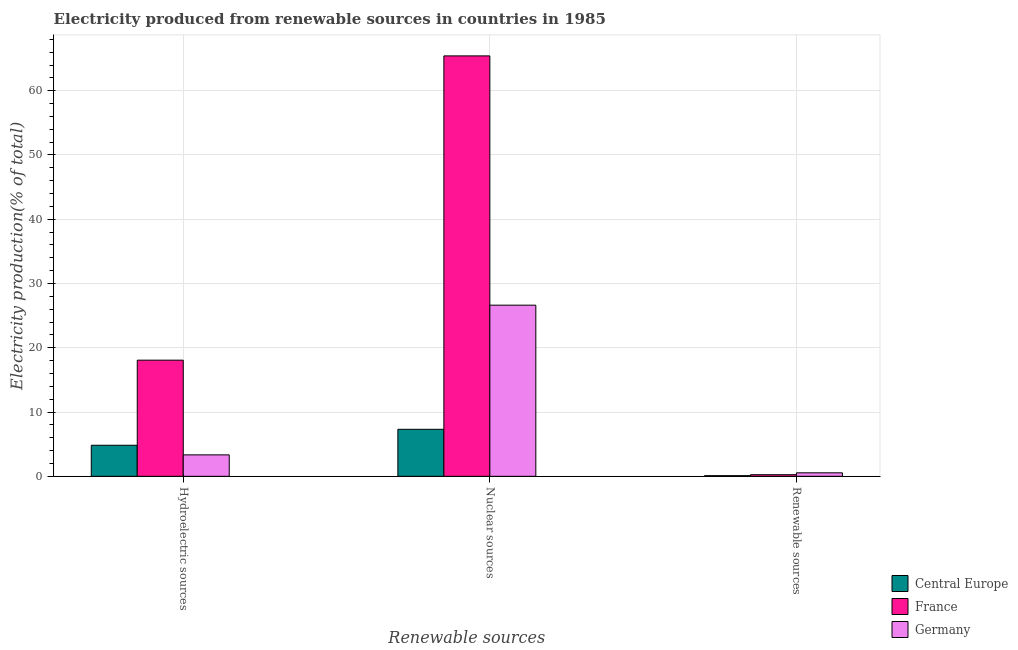How many different coloured bars are there?
Make the answer very short. 3. How many groups of bars are there?
Provide a short and direct response. 3. What is the label of the 3rd group of bars from the left?
Your answer should be very brief. Renewable sources. What is the percentage of electricity produced by renewable sources in Germany?
Your answer should be compact. 0.54. Across all countries, what is the maximum percentage of electricity produced by nuclear sources?
Give a very brief answer. 65.42. Across all countries, what is the minimum percentage of electricity produced by hydroelectric sources?
Ensure brevity in your answer.  3.34. What is the total percentage of electricity produced by renewable sources in the graph?
Your answer should be compact. 0.89. What is the difference between the percentage of electricity produced by hydroelectric sources in Central Europe and that in Germany?
Your response must be concise. 1.5. What is the difference between the percentage of electricity produced by hydroelectric sources in Germany and the percentage of electricity produced by renewable sources in Central Europe?
Provide a succinct answer. 3.24. What is the average percentage of electricity produced by hydroelectric sources per country?
Give a very brief answer. 8.75. What is the difference between the percentage of electricity produced by hydroelectric sources and percentage of electricity produced by nuclear sources in Central Europe?
Your response must be concise. -2.48. In how many countries, is the percentage of electricity produced by renewable sources greater than 8 %?
Keep it short and to the point. 0. What is the ratio of the percentage of electricity produced by nuclear sources in France to that in Central Europe?
Offer a very short reply. 8.94. What is the difference between the highest and the second highest percentage of electricity produced by renewable sources?
Provide a succinct answer. 0.29. What is the difference between the highest and the lowest percentage of electricity produced by renewable sources?
Provide a succinct answer. 0.44. What does the 1st bar from the left in Hydroelectric sources represents?
Keep it short and to the point. Central Europe. What does the 3rd bar from the right in Hydroelectric sources represents?
Your answer should be compact. Central Europe. Is it the case that in every country, the sum of the percentage of electricity produced by hydroelectric sources and percentage of electricity produced by nuclear sources is greater than the percentage of electricity produced by renewable sources?
Offer a terse response. Yes. Are all the bars in the graph horizontal?
Offer a terse response. No. Are the values on the major ticks of Y-axis written in scientific E-notation?
Your answer should be compact. No. How many legend labels are there?
Keep it short and to the point. 3. What is the title of the graph?
Keep it short and to the point. Electricity produced from renewable sources in countries in 1985. Does "Chile" appear as one of the legend labels in the graph?
Offer a terse response. No. What is the label or title of the X-axis?
Your answer should be very brief. Renewable sources. What is the label or title of the Y-axis?
Offer a very short reply. Electricity production(% of total). What is the Electricity production(% of total) of Central Europe in Hydroelectric sources?
Ensure brevity in your answer.  4.83. What is the Electricity production(% of total) of France in Hydroelectric sources?
Provide a succinct answer. 18.07. What is the Electricity production(% of total) in Germany in Hydroelectric sources?
Make the answer very short. 3.34. What is the Electricity production(% of total) of Central Europe in Nuclear sources?
Make the answer very short. 7.31. What is the Electricity production(% of total) of France in Nuclear sources?
Make the answer very short. 65.42. What is the Electricity production(% of total) of Germany in Nuclear sources?
Your response must be concise. 26.63. What is the Electricity production(% of total) of Central Europe in Renewable sources?
Provide a short and direct response. 0.1. What is the Electricity production(% of total) in France in Renewable sources?
Offer a terse response. 0.25. What is the Electricity production(% of total) in Germany in Renewable sources?
Provide a short and direct response. 0.54. Across all Renewable sources, what is the maximum Electricity production(% of total) in Central Europe?
Provide a short and direct response. 7.31. Across all Renewable sources, what is the maximum Electricity production(% of total) of France?
Your response must be concise. 65.42. Across all Renewable sources, what is the maximum Electricity production(% of total) of Germany?
Provide a succinct answer. 26.63. Across all Renewable sources, what is the minimum Electricity production(% of total) of Central Europe?
Keep it short and to the point. 0.1. Across all Renewable sources, what is the minimum Electricity production(% of total) of France?
Ensure brevity in your answer.  0.25. Across all Renewable sources, what is the minimum Electricity production(% of total) of Germany?
Your answer should be compact. 0.54. What is the total Electricity production(% of total) of Central Europe in the graph?
Your response must be concise. 12.25. What is the total Electricity production(% of total) of France in the graph?
Your answer should be very brief. 83.75. What is the total Electricity production(% of total) in Germany in the graph?
Provide a short and direct response. 30.51. What is the difference between the Electricity production(% of total) of Central Europe in Hydroelectric sources and that in Nuclear sources?
Give a very brief answer. -2.48. What is the difference between the Electricity production(% of total) in France in Hydroelectric sources and that in Nuclear sources?
Your answer should be very brief. -47.35. What is the difference between the Electricity production(% of total) of Germany in Hydroelectric sources and that in Nuclear sources?
Keep it short and to the point. -23.3. What is the difference between the Electricity production(% of total) in Central Europe in Hydroelectric sources and that in Renewable sources?
Your answer should be very brief. 4.73. What is the difference between the Electricity production(% of total) in France in Hydroelectric sources and that in Renewable sources?
Your answer should be very brief. 17.82. What is the difference between the Electricity production(% of total) in Germany in Hydroelectric sources and that in Renewable sources?
Keep it short and to the point. 2.79. What is the difference between the Electricity production(% of total) of Central Europe in Nuclear sources and that in Renewable sources?
Your answer should be compact. 7.22. What is the difference between the Electricity production(% of total) in France in Nuclear sources and that in Renewable sources?
Offer a very short reply. 65.17. What is the difference between the Electricity production(% of total) of Germany in Nuclear sources and that in Renewable sources?
Provide a short and direct response. 26.09. What is the difference between the Electricity production(% of total) in Central Europe in Hydroelectric sources and the Electricity production(% of total) in France in Nuclear sources?
Give a very brief answer. -60.59. What is the difference between the Electricity production(% of total) of Central Europe in Hydroelectric sources and the Electricity production(% of total) of Germany in Nuclear sources?
Offer a very short reply. -21.8. What is the difference between the Electricity production(% of total) in France in Hydroelectric sources and the Electricity production(% of total) in Germany in Nuclear sources?
Make the answer very short. -8.56. What is the difference between the Electricity production(% of total) of Central Europe in Hydroelectric sources and the Electricity production(% of total) of France in Renewable sources?
Make the answer very short. 4.58. What is the difference between the Electricity production(% of total) in Central Europe in Hydroelectric sources and the Electricity production(% of total) in Germany in Renewable sources?
Provide a short and direct response. 4.29. What is the difference between the Electricity production(% of total) in France in Hydroelectric sources and the Electricity production(% of total) in Germany in Renewable sources?
Give a very brief answer. 17.53. What is the difference between the Electricity production(% of total) in Central Europe in Nuclear sources and the Electricity production(% of total) in France in Renewable sources?
Offer a terse response. 7.06. What is the difference between the Electricity production(% of total) in Central Europe in Nuclear sources and the Electricity production(% of total) in Germany in Renewable sources?
Offer a terse response. 6.77. What is the difference between the Electricity production(% of total) in France in Nuclear sources and the Electricity production(% of total) in Germany in Renewable sources?
Provide a succinct answer. 64.88. What is the average Electricity production(% of total) in Central Europe per Renewable sources?
Offer a terse response. 4.08. What is the average Electricity production(% of total) of France per Renewable sources?
Your response must be concise. 27.92. What is the average Electricity production(% of total) in Germany per Renewable sources?
Your response must be concise. 10.17. What is the difference between the Electricity production(% of total) in Central Europe and Electricity production(% of total) in France in Hydroelectric sources?
Offer a very short reply. -13.24. What is the difference between the Electricity production(% of total) in Central Europe and Electricity production(% of total) in Germany in Hydroelectric sources?
Give a very brief answer. 1.5. What is the difference between the Electricity production(% of total) in France and Electricity production(% of total) in Germany in Hydroelectric sources?
Provide a short and direct response. 14.74. What is the difference between the Electricity production(% of total) of Central Europe and Electricity production(% of total) of France in Nuclear sources?
Give a very brief answer. -58.11. What is the difference between the Electricity production(% of total) of Central Europe and Electricity production(% of total) of Germany in Nuclear sources?
Offer a terse response. -19.32. What is the difference between the Electricity production(% of total) in France and Electricity production(% of total) in Germany in Nuclear sources?
Provide a succinct answer. 38.79. What is the difference between the Electricity production(% of total) of Central Europe and Electricity production(% of total) of France in Renewable sources?
Keep it short and to the point. -0.15. What is the difference between the Electricity production(% of total) in Central Europe and Electricity production(% of total) in Germany in Renewable sources?
Provide a short and direct response. -0.44. What is the difference between the Electricity production(% of total) of France and Electricity production(% of total) of Germany in Renewable sources?
Give a very brief answer. -0.29. What is the ratio of the Electricity production(% of total) in Central Europe in Hydroelectric sources to that in Nuclear sources?
Your answer should be very brief. 0.66. What is the ratio of the Electricity production(% of total) in France in Hydroelectric sources to that in Nuclear sources?
Ensure brevity in your answer.  0.28. What is the ratio of the Electricity production(% of total) of Germany in Hydroelectric sources to that in Nuclear sources?
Provide a succinct answer. 0.13. What is the ratio of the Electricity production(% of total) of Central Europe in Hydroelectric sources to that in Renewable sources?
Your answer should be compact. 48.58. What is the ratio of the Electricity production(% of total) in France in Hydroelectric sources to that in Renewable sources?
Your answer should be very brief. 72.16. What is the ratio of the Electricity production(% of total) in Germany in Hydroelectric sources to that in Renewable sources?
Provide a succinct answer. 6.13. What is the ratio of the Electricity production(% of total) of Central Europe in Nuclear sources to that in Renewable sources?
Ensure brevity in your answer.  73.51. What is the ratio of the Electricity production(% of total) of France in Nuclear sources to that in Renewable sources?
Offer a very short reply. 261.19. What is the ratio of the Electricity production(% of total) of Germany in Nuclear sources to that in Renewable sources?
Give a very brief answer. 48.96. What is the difference between the highest and the second highest Electricity production(% of total) of Central Europe?
Provide a short and direct response. 2.48. What is the difference between the highest and the second highest Electricity production(% of total) of France?
Your response must be concise. 47.35. What is the difference between the highest and the second highest Electricity production(% of total) in Germany?
Keep it short and to the point. 23.3. What is the difference between the highest and the lowest Electricity production(% of total) of Central Europe?
Keep it short and to the point. 7.22. What is the difference between the highest and the lowest Electricity production(% of total) in France?
Your answer should be very brief. 65.17. What is the difference between the highest and the lowest Electricity production(% of total) of Germany?
Your response must be concise. 26.09. 